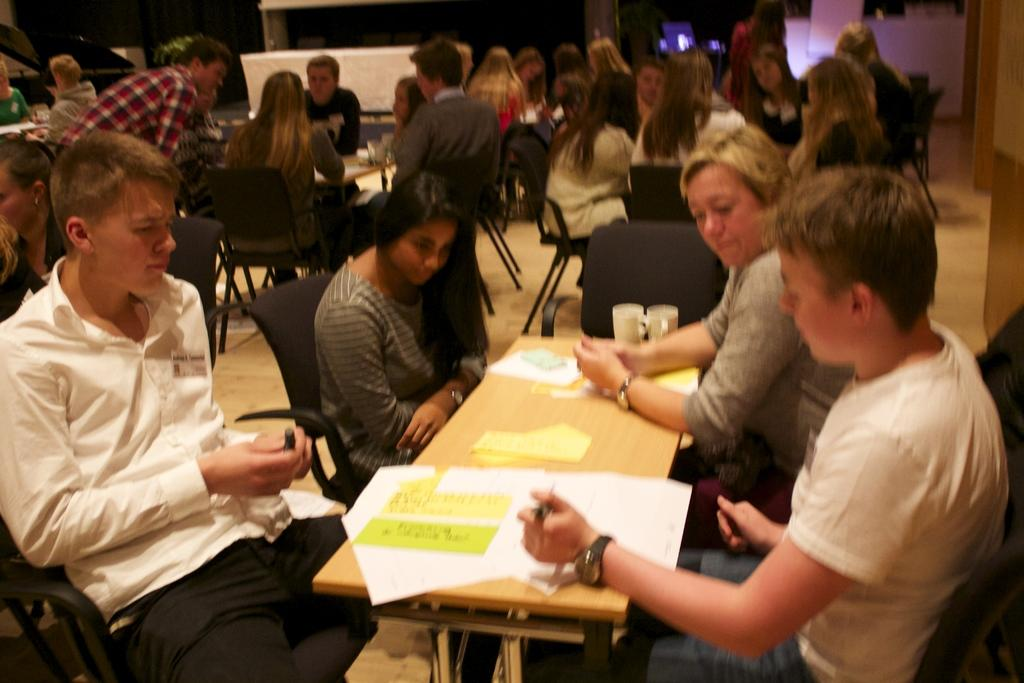How many people are in the image? There is a group of people in the image. What are the people doing in the image? The people are sitting on chairs. What is on the table in the image? There is a paper and two glasses on the table. What can be seen in the background of the image? There is a wooden wall in the background. What type of stone is being used for the discussion in the image? There is no discussion or stone present in the image. 